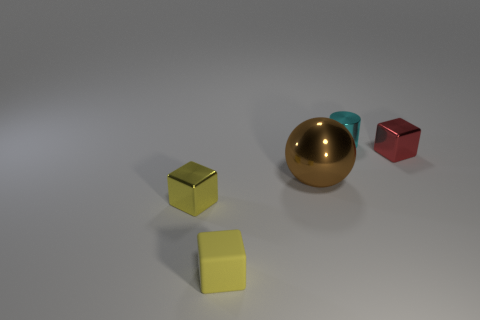How many metal things are there?
Your response must be concise. 4. What size is the thing that is on the right side of the rubber block and in front of the red object?
Give a very brief answer. Large. The red thing that is the same size as the cylinder is what shape?
Keep it short and to the point. Cube. Is there a small thing that is to the right of the tiny shiny object left of the shiny cylinder?
Your answer should be compact. Yes. What is the color of the rubber thing that is the same shape as the small yellow metallic thing?
Offer a very short reply. Yellow. Does the metallic block in front of the brown shiny object have the same color as the rubber block?
Keep it short and to the point. Yes. What number of things are either shiny objects that are right of the tiny yellow metallic cube or small things?
Make the answer very short. 5. The block behind the small shiny block to the left of the small thing on the right side of the small cyan cylinder is made of what material?
Keep it short and to the point. Metal. Are there more objects on the right side of the cyan metal cylinder than yellow metallic objects that are on the left side of the yellow metallic cube?
Give a very brief answer. Yes. What number of spheres are things or yellow shiny things?
Your response must be concise. 1. 